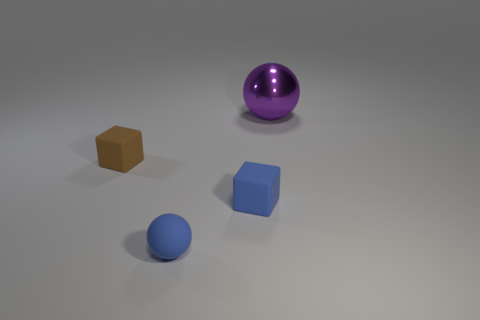What number of objects are either matte objects that are behind the small blue cube or spheres left of the purple metal thing?
Ensure brevity in your answer.  2. What is the shape of the brown rubber thing that is the same size as the matte sphere?
Provide a short and direct response. Cube. The brown object that is the same material as the blue block is what size?
Provide a short and direct response. Small. Does the shiny object have the same shape as the brown matte thing?
Keep it short and to the point. No. The rubber sphere that is the same size as the blue block is what color?
Give a very brief answer. Blue. What is the size of the other thing that is the same shape as the large metallic object?
Keep it short and to the point. Small. There is a tiny blue rubber thing that is to the right of the small blue matte sphere; what is its shape?
Offer a very short reply. Cube. Does the purple shiny thing have the same shape as the blue object in front of the blue matte block?
Offer a terse response. Yes. Are there the same number of tiny rubber things that are on the right side of the purple metal ball and purple shiny spheres that are right of the blue sphere?
Keep it short and to the point. No. The thing that is the same color as the matte ball is what shape?
Offer a very short reply. Cube. 